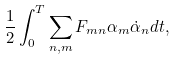<formula> <loc_0><loc_0><loc_500><loc_500>\frac { 1 } { 2 } \int _ { 0 } ^ { T } \sum _ { n , m } F _ { m n } \alpha _ { m } \dot { \alpha } _ { n } d t ,</formula> 